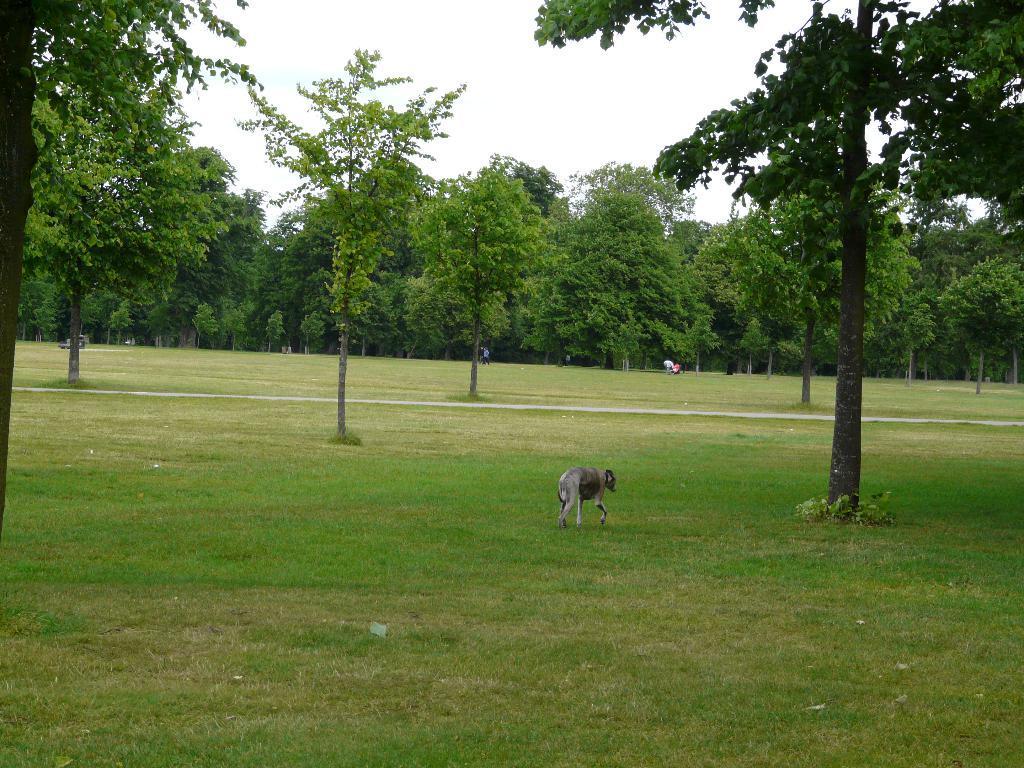Could you give a brief overview of what you see in this image? In this image we can see an animal is walking on the grassland. Here we can see a few people in the background, we can see trees and the sky. 